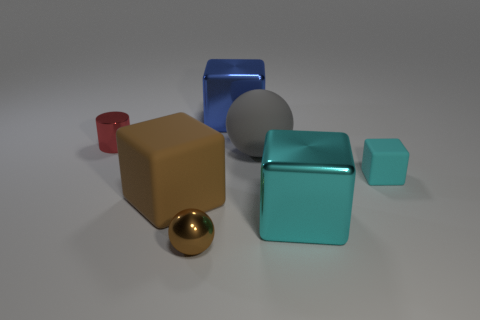Add 1 big brown matte blocks. How many objects exist? 8 Subtract all cylinders. How many objects are left? 6 Subtract all blocks. Subtract all tiny metal cylinders. How many objects are left? 2 Add 2 large things. How many large things are left? 6 Add 6 large blue shiny cubes. How many large blue shiny cubes exist? 7 Subtract 1 gray spheres. How many objects are left? 6 